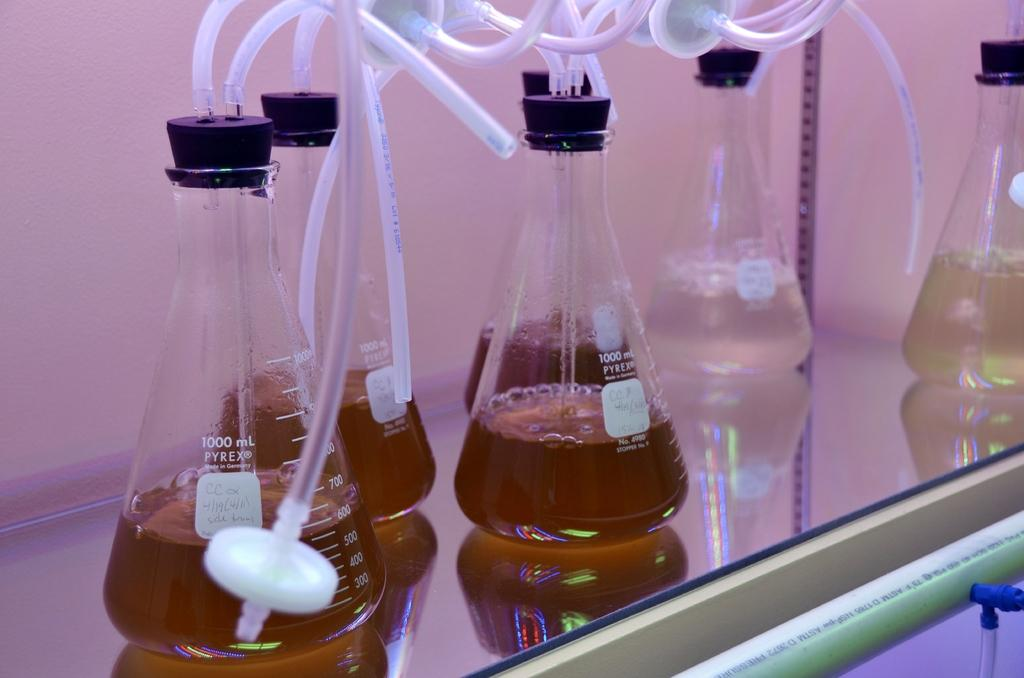Provide a one-sentence caption for the provided image. Six Pyrex Vials with different tubes running in and out of them. 